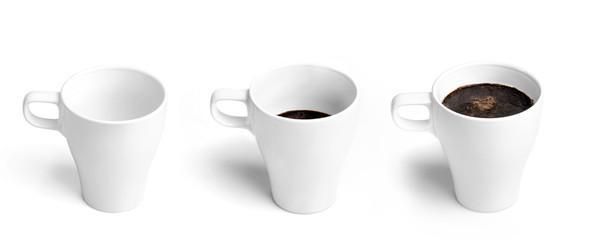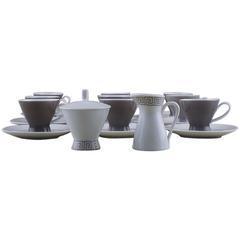The first image is the image on the left, the second image is the image on the right. Assess this claim about the two images: "There are three mugs in one of the images.". Correct or not? Answer yes or no. Yes. The first image is the image on the left, the second image is the image on the right. For the images shown, is this caption "An image shows a row of three cups that are upside-down." true? Answer yes or no. No. 